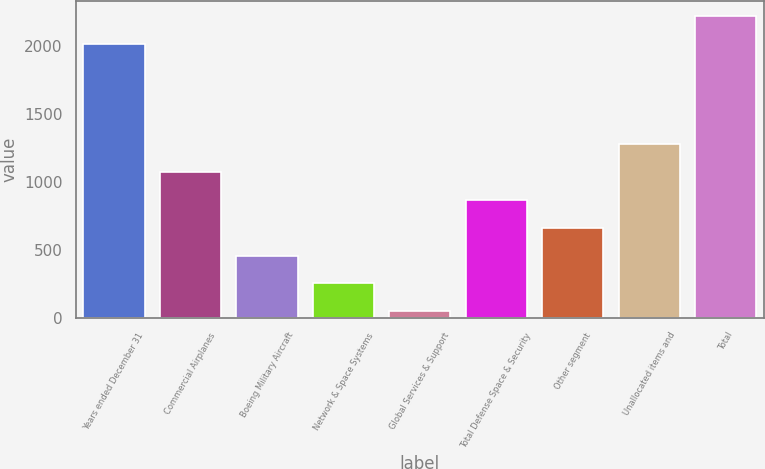<chart> <loc_0><loc_0><loc_500><loc_500><bar_chart><fcel>Years ended December 31<fcel>Commercial Airplanes<fcel>Boeing Military Aircraft<fcel>Network & Space Systems<fcel>Global Services & Support<fcel>Total Defense Space & Security<fcel>Other segment<fcel>Unallocated items and<fcel>Total<nl><fcel>2013<fcel>1073<fcel>458<fcel>253<fcel>48<fcel>868<fcel>663<fcel>1278<fcel>2218<nl></chart> 